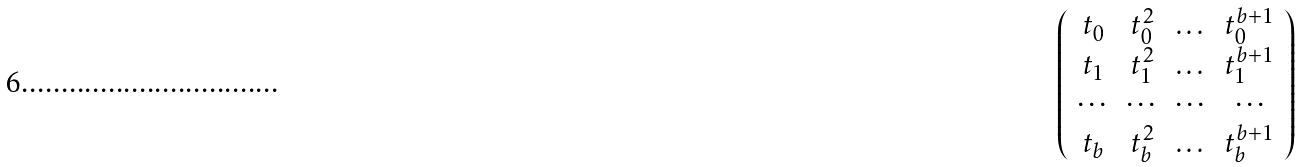Convert formula to latex. <formula><loc_0><loc_0><loc_500><loc_500>\left ( \begin{array} { c c c c } t _ { 0 } & t _ { 0 } ^ { 2 } & \dots & t _ { 0 } ^ { b + 1 } \\ t _ { 1 } & t _ { 1 } ^ { 2 } & \dots & t _ { 1 } ^ { b + 1 } \\ \cdots & \cdots & \cdots & \cdots \\ t _ { b } & t _ { b } ^ { 2 } & \dots & t _ { b } ^ { b + 1 } \end{array} \right )</formula> 